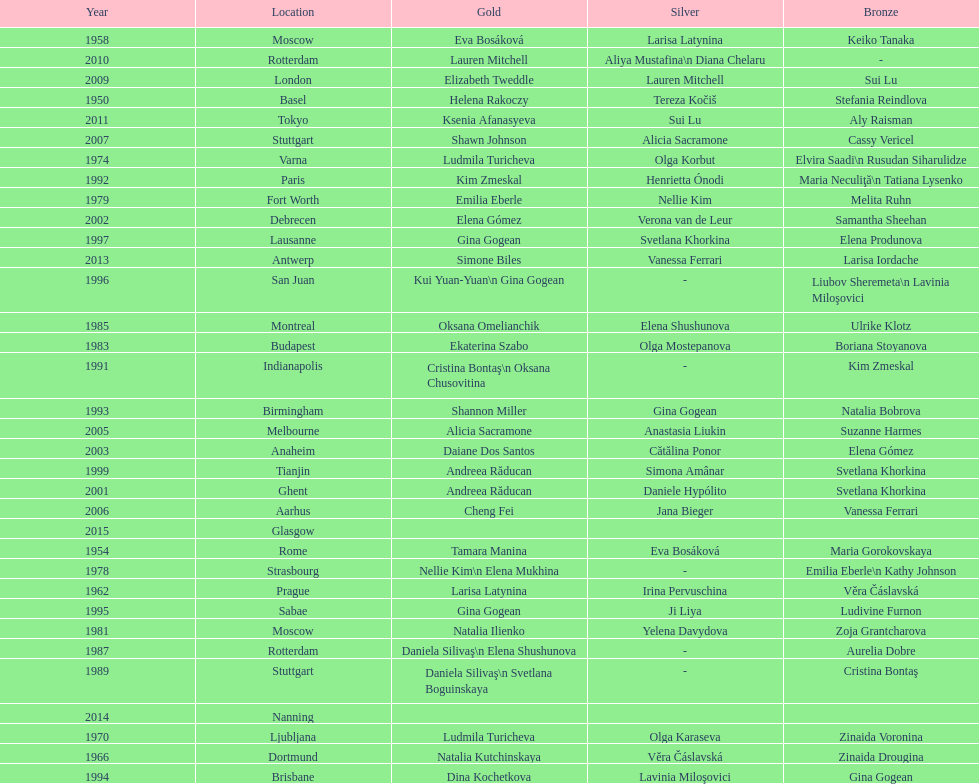How many consecutive floor exercise gold medals did romanian star andreea raducan win at the world championships? 2. 